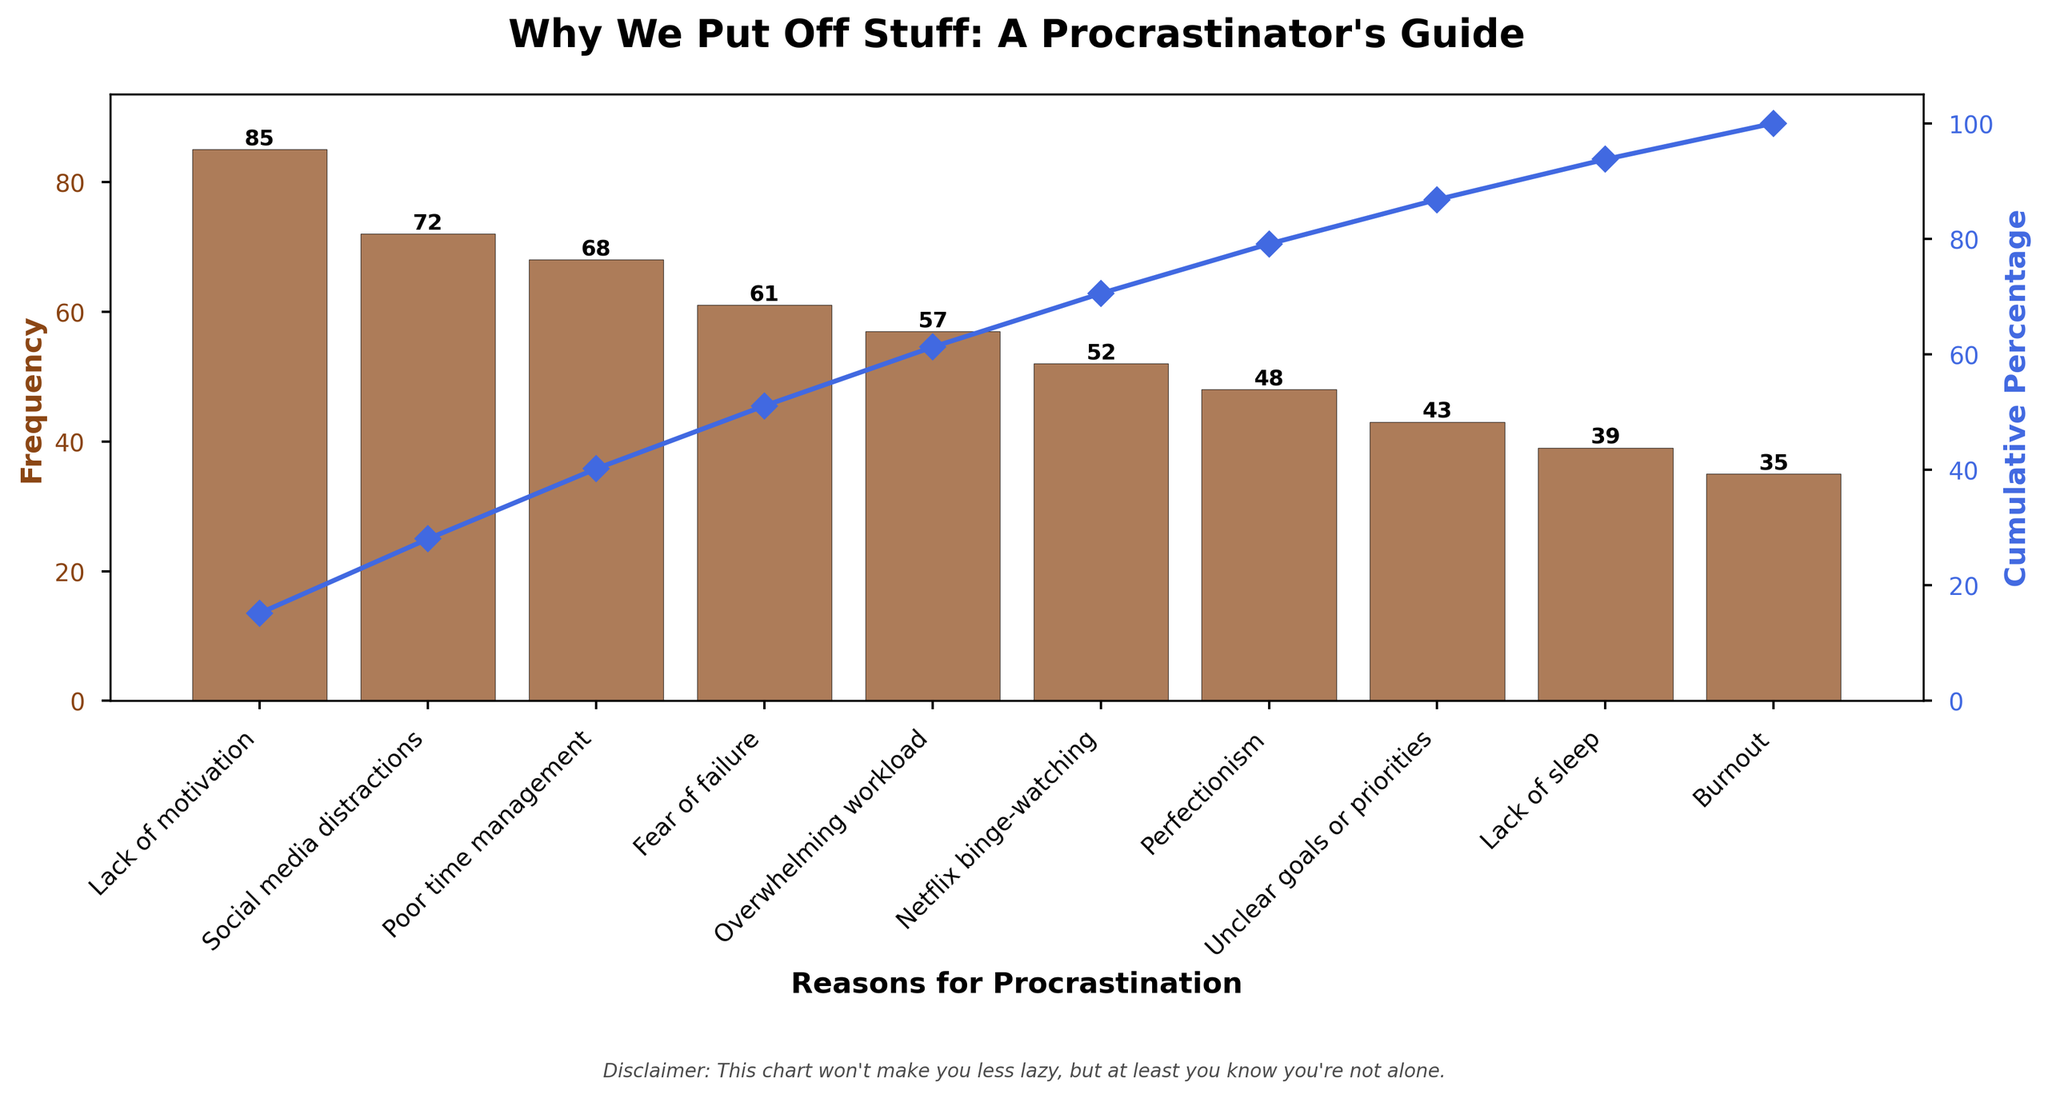What's the title of the figure? The title is displayed at the top of the figure. It reads "Why We Put Off Stuff: A Procrastinator's Guide".
Answer: Why We Put Off Stuff: A Procrastinator's Guide What are the two axes labeled? The y-axes are labeled "Frequency" on the left, which represents the number of occurrences, and "Cumulative Percentage" on the right, which represents the cumulative percentage of the reasons listed.
Answer: Frequency and Cumulative Percentage Which reason for procrastination is the most frequent? The most frequent reason for procrastination is the one with the highest bar, which is "Lack of motivation" with a frequency of 85.
Answer: Lack of motivation What's the combined frequency of the top three reasons for procrastination? Adding the frequencies of the top three reasons: Lack of motivation (85), Social media distractions (72), and Poor time management (68), we get 85 + 72 + 68 = 225.
Answer: 225 Which reason for procrastination is the least frequent? The least frequent reason is the one with the shortest bar, which is "Burnout" with a frequency of 35.
Answer: Burnout How much higher is the frequency of "Lack of motivation" compared to "Netflix binge-watching"? Subtract the frequency of "Netflix binge-watching" (52) from "Lack of motivation" (85), giving 85 - 52 = 33.
Answer: 33 What's the cumulative percentage after the top four reasons for procrastination? Adding the cumulative percentages of the top four reasons: Lack of motivation (29.3%), Social media distractions (54.1%), Poor time management (77.6%), and Fear of failure (98.7%), we get approximately 100%.
Answer: 98.7% What's the average frequency across all reasons for procrastination listed? Sum the frequencies (85 + 72 + 68 + 61 + 57 + 52 + 48 + 43 + 39 + 35 = 560) and divide by the number of reasons (10), giving 560 / 10 = 56.
Answer: 56 What percentage of the reasons account for over 50% cumulative procrastination? By observing the cumulative percentage curve, after the second reason ("Social media distractions"), the cumulative percentage surpasses 50%. Thus, 20% of the reasons account for over 50% cumulative procrastination.
Answer: 20% 